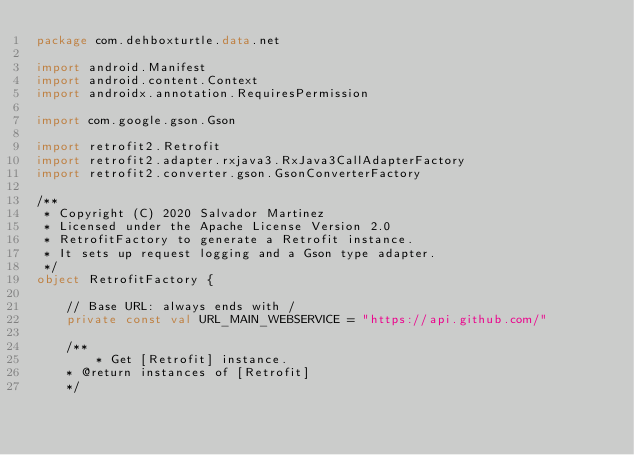<code> <loc_0><loc_0><loc_500><loc_500><_Kotlin_>package com.dehboxturtle.data.net

import android.Manifest
import android.content.Context
import androidx.annotation.RequiresPermission

import com.google.gson.Gson

import retrofit2.Retrofit
import retrofit2.adapter.rxjava3.RxJava3CallAdapterFactory
import retrofit2.converter.gson.GsonConverterFactory

/**
 * Copyright (C) 2020 Salvador Martinez
 * Licensed under the Apache License Version 2.0
 * RetrofitFactory to generate a Retrofit instance.
 * It sets up request logging and a Gson type adapter.
 */
object RetrofitFactory {

    // Base URL: always ends with /
    private const val URL_MAIN_WEBSERVICE = "https://api.github.com/"

    /**
        * Get [Retrofit] instance.
    * @return instances of [Retrofit]
    */</code> 